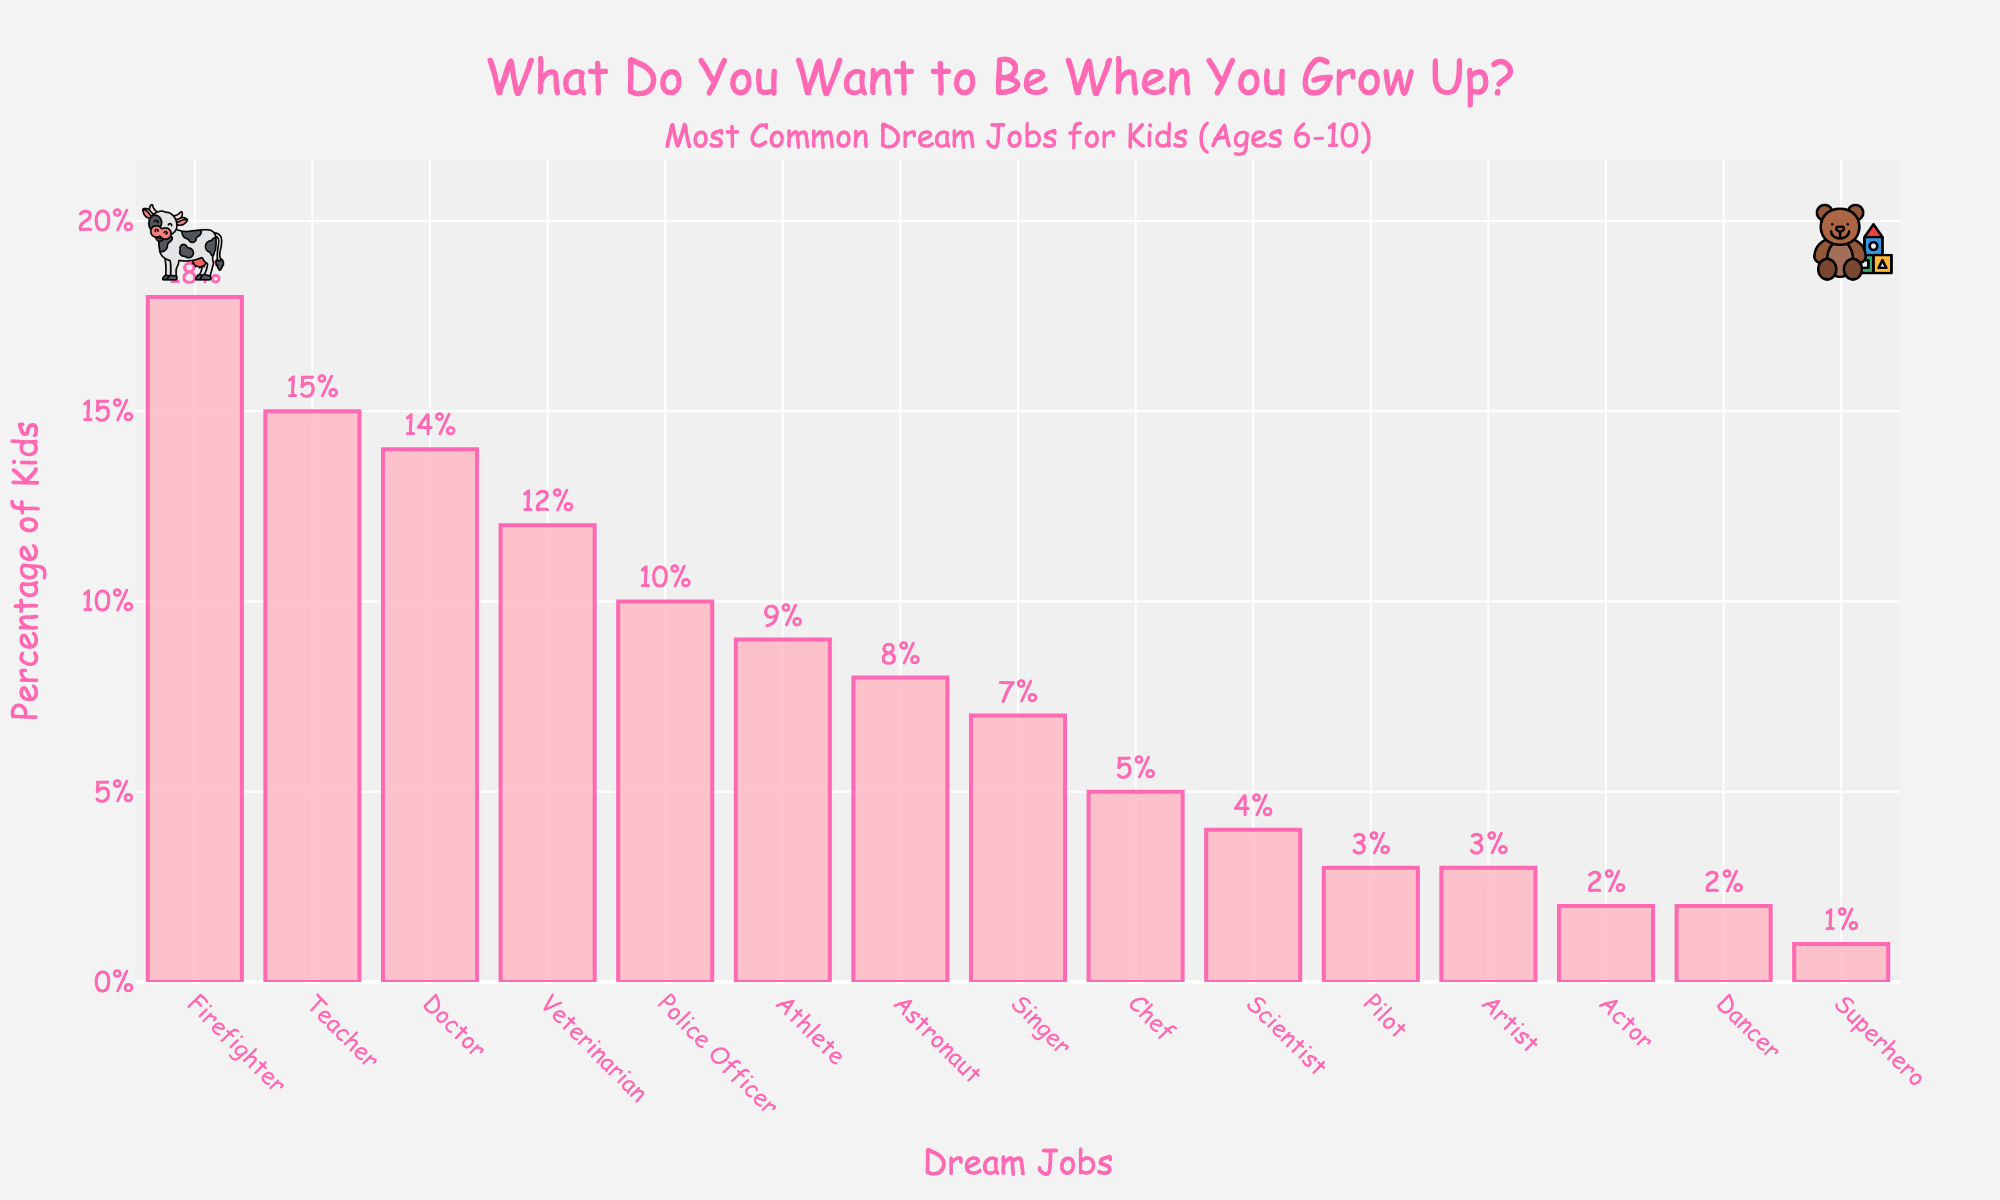What is the most common dream job for kids aged 6-10? Look at the bar chart and find the tallest bar. The occupation associated with this bar is the most common dream job for kids aged 6-10.
Answer: Firefighter Which job is more popular, Doctor or Police Officer? Find the bars associated with Doctor and Police Officer. Compare their heights or percentages.
Answer: Doctor What's the combined percentage of kids who want to be a Teacher or a Veterinarian? Identify the percentages for Teacher (15%) and Veterinarian (12%). Add these percentages together: 15% + 12% = 27%
Answer: 27% Are there any jobs that have the same percentage of kids wanting to do them? Look at the bars' heights or percentages. Identify if any two occupations share the same percentage.
Answer: Yes, Pilot and Artist (3%) and Actor and Dancer (2%) How many percentage points higher is the popularity of being a Firefighter compared to being an Astronaut? Find the percentages for Firefighter (18%) and Astronaut (8%). Subtract the lower percentage from the higher one: 18% - 8% = 10%
Answer: 10% What is the least popular dream job for kids aged 6-10? Look at the bar chart and find the shortest bar. The occupation associated with this bar is the least popular dream job for kids aged 6-10.
Answer: Superhero How does the percentage of kids wanting to be a Singer compare to those wanting to be an Athlete? Compare the percentages for Singer (7%) and Athlete (9%) by identifying which one is higher.
Answer: Athlete What's the total percentage of kids who want to become either a Doctor, a Teacher, or a Firefighter? Sum the percentages for Doctor (14%), Teacher (15%), and Firefighter (18%): 14% + 15% + 18% = 47%
Answer: 47% How many jobs have a percentage less than or equal to 5%? Identify the bars with percentages equal to or less than 5%: Chef (5%), Scientist (4%), Pilot (3%), Artist (3%), Actor (2%), Dancer (2%), Superhero (1%). Count these occupations.
Answer: 7 